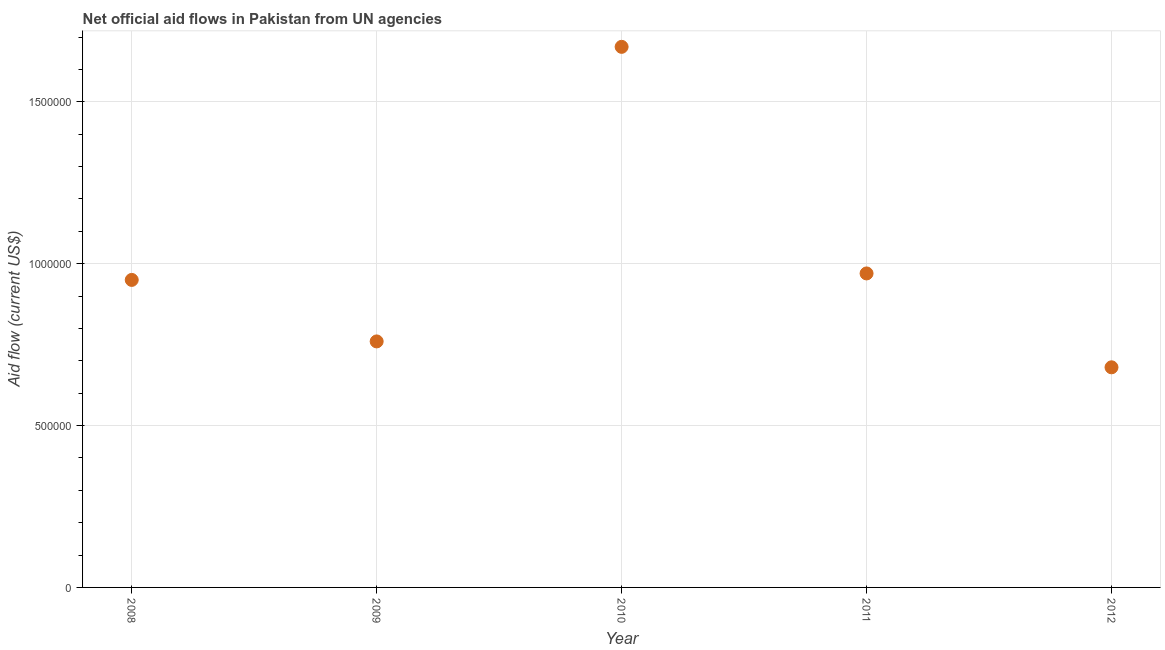What is the net official flows from un agencies in 2011?
Give a very brief answer. 9.70e+05. Across all years, what is the maximum net official flows from un agencies?
Make the answer very short. 1.67e+06. Across all years, what is the minimum net official flows from un agencies?
Give a very brief answer. 6.80e+05. What is the sum of the net official flows from un agencies?
Your answer should be very brief. 5.03e+06. What is the difference between the net official flows from un agencies in 2008 and 2011?
Make the answer very short. -2.00e+04. What is the average net official flows from un agencies per year?
Offer a very short reply. 1.01e+06. What is the median net official flows from un agencies?
Give a very brief answer. 9.50e+05. In how many years, is the net official flows from un agencies greater than 1400000 US$?
Your response must be concise. 1. What is the ratio of the net official flows from un agencies in 2008 to that in 2010?
Give a very brief answer. 0.57. Is the difference between the net official flows from un agencies in 2008 and 2011 greater than the difference between any two years?
Keep it short and to the point. No. What is the difference between the highest and the second highest net official flows from un agencies?
Make the answer very short. 7.00e+05. Is the sum of the net official flows from un agencies in 2008 and 2009 greater than the maximum net official flows from un agencies across all years?
Keep it short and to the point. Yes. What is the difference between the highest and the lowest net official flows from un agencies?
Keep it short and to the point. 9.90e+05. In how many years, is the net official flows from un agencies greater than the average net official flows from un agencies taken over all years?
Offer a terse response. 1. How many dotlines are there?
Provide a short and direct response. 1. How many years are there in the graph?
Your response must be concise. 5. Are the values on the major ticks of Y-axis written in scientific E-notation?
Make the answer very short. No. What is the title of the graph?
Offer a very short reply. Net official aid flows in Pakistan from UN agencies. What is the Aid flow (current US$) in 2008?
Keep it short and to the point. 9.50e+05. What is the Aid flow (current US$) in 2009?
Provide a succinct answer. 7.60e+05. What is the Aid flow (current US$) in 2010?
Your answer should be very brief. 1.67e+06. What is the Aid flow (current US$) in 2011?
Provide a short and direct response. 9.70e+05. What is the Aid flow (current US$) in 2012?
Make the answer very short. 6.80e+05. What is the difference between the Aid flow (current US$) in 2008 and 2010?
Give a very brief answer. -7.20e+05. What is the difference between the Aid flow (current US$) in 2009 and 2010?
Make the answer very short. -9.10e+05. What is the difference between the Aid flow (current US$) in 2009 and 2011?
Your answer should be very brief. -2.10e+05. What is the difference between the Aid flow (current US$) in 2010 and 2011?
Keep it short and to the point. 7.00e+05. What is the difference between the Aid flow (current US$) in 2010 and 2012?
Keep it short and to the point. 9.90e+05. What is the ratio of the Aid flow (current US$) in 2008 to that in 2010?
Ensure brevity in your answer.  0.57. What is the ratio of the Aid flow (current US$) in 2008 to that in 2011?
Provide a succinct answer. 0.98. What is the ratio of the Aid flow (current US$) in 2008 to that in 2012?
Offer a very short reply. 1.4. What is the ratio of the Aid flow (current US$) in 2009 to that in 2010?
Ensure brevity in your answer.  0.46. What is the ratio of the Aid flow (current US$) in 2009 to that in 2011?
Offer a terse response. 0.78. What is the ratio of the Aid flow (current US$) in 2009 to that in 2012?
Provide a succinct answer. 1.12. What is the ratio of the Aid flow (current US$) in 2010 to that in 2011?
Offer a terse response. 1.72. What is the ratio of the Aid flow (current US$) in 2010 to that in 2012?
Offer a terse response. 2.46. What is the ratio of the Aid flow (current US$) in 2011 to that in 2012?
Offer a very short reply. 1.43. 